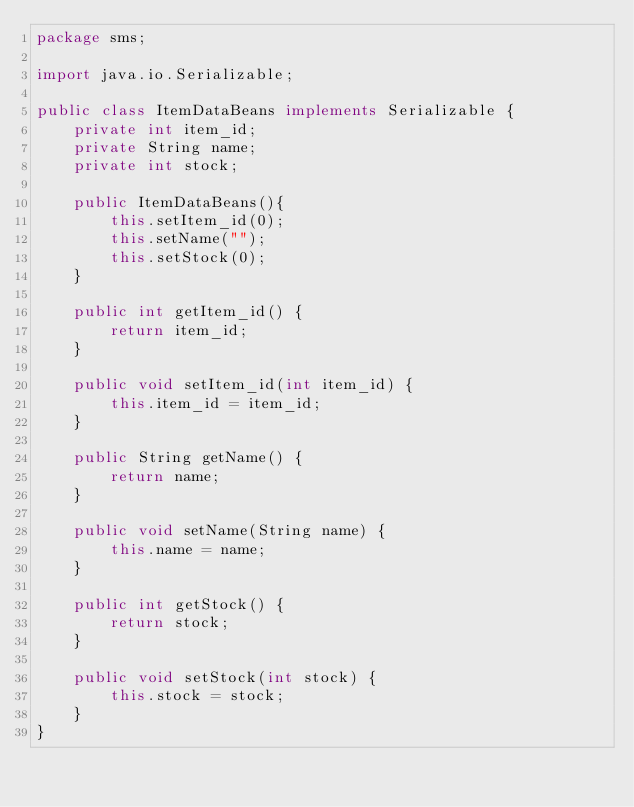Convert code to text. <code><loc_0><loc_0><loc_500><loc_500><_Java_>package sms;

import java.io.Serializable;

public class ItemDataBeans implements Serializable {
	private int item_id;
	private String name;
	private int stock;

	public ItemDataBeans(){
        this.setItem_id(0);
        this.setName("");
        this.setStock(0);
    }

	public int getItem_id() {
		return item_id;
	}

	public void setItem_id(int item_id) {
		this.item_id = item_id;
	}

	public String getName() {
		return name;
	}

	public void setName(String name) {
		this.name = name;
	}

	public int getStock() {
		return stock;
	}

	public void setStock(int stock) {
		this.stock = stock;
	}
}
</code> 